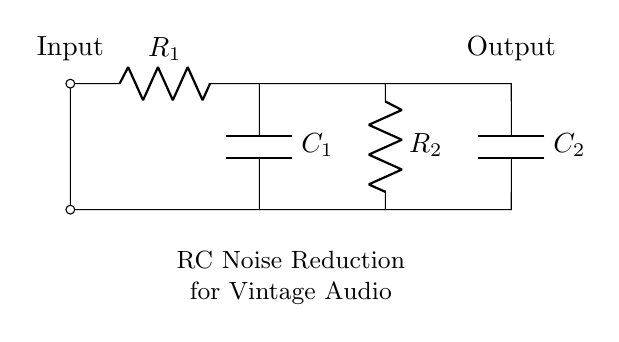What are the two types of components used in this circuit? The circuit diagram shows two types of components: resistors and capacitors. Resistors limit current flow and capacitors store electrical energy.
Answer: resistors and capacitors What is the function of the capacitor C1? The capacitor C1 acts as a coupling capacitor, allowing AC signals to pass while blocking DC, thereby helping to reduce noise in the audio signal.
Answer: coupling What is the configuration of R1 and C1 in the circuit? R1 and C1 are in series, meaning they are connected one after another, which influences the timing and frequency response of the circuit.
Answer: series What is the total number of resistors in the circuit? The diagram shows two resistors labeled R1 and R2, indicating that there are a total of two resistors in the circuit.
Answer: two What happens to high-frequency noise in this RC circuit? High-frequency noise is attenuated as it passes through a resistor-capacitor circuit, which effectively reduces the amplitude of those noises, enhancing the audio quality.
Answer: attenuated What is the primary application of this RC-based circuit? The primary application of this circuit is noise reduction, specifically suited for vintage audio equipment to improve sound quality by filtering out unwanted noise.
Answer: noise reduction 